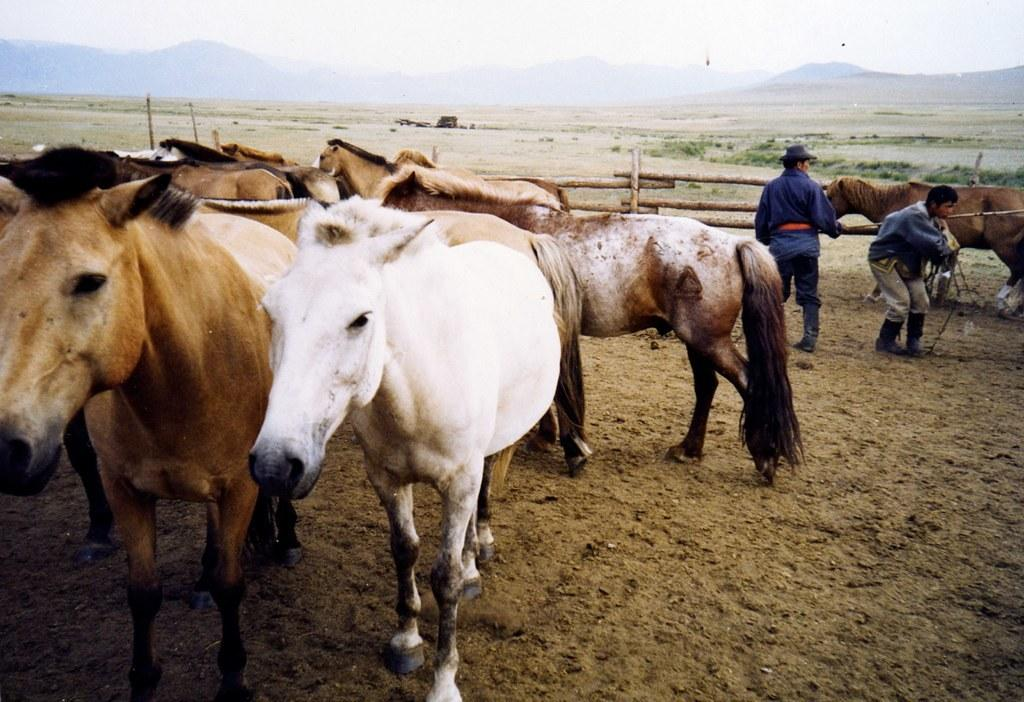What animals can be seen in the image? There are horses in the image. How many people are present in the image? There are two persons in the image. What is the barrier between the horses and the people? There is a wooden fence in the image. What can be seen in the distance in the image? Hills and the sky are visible in the background of the image. What is one person wearing on their head? One person is wearing a hat. What type of chicken can be seen in the image? There is no chicken present in the image; it features horses and people. How does the shock affect the horses in the image? There is no shock present in the image, so it cannot affect the horses. 